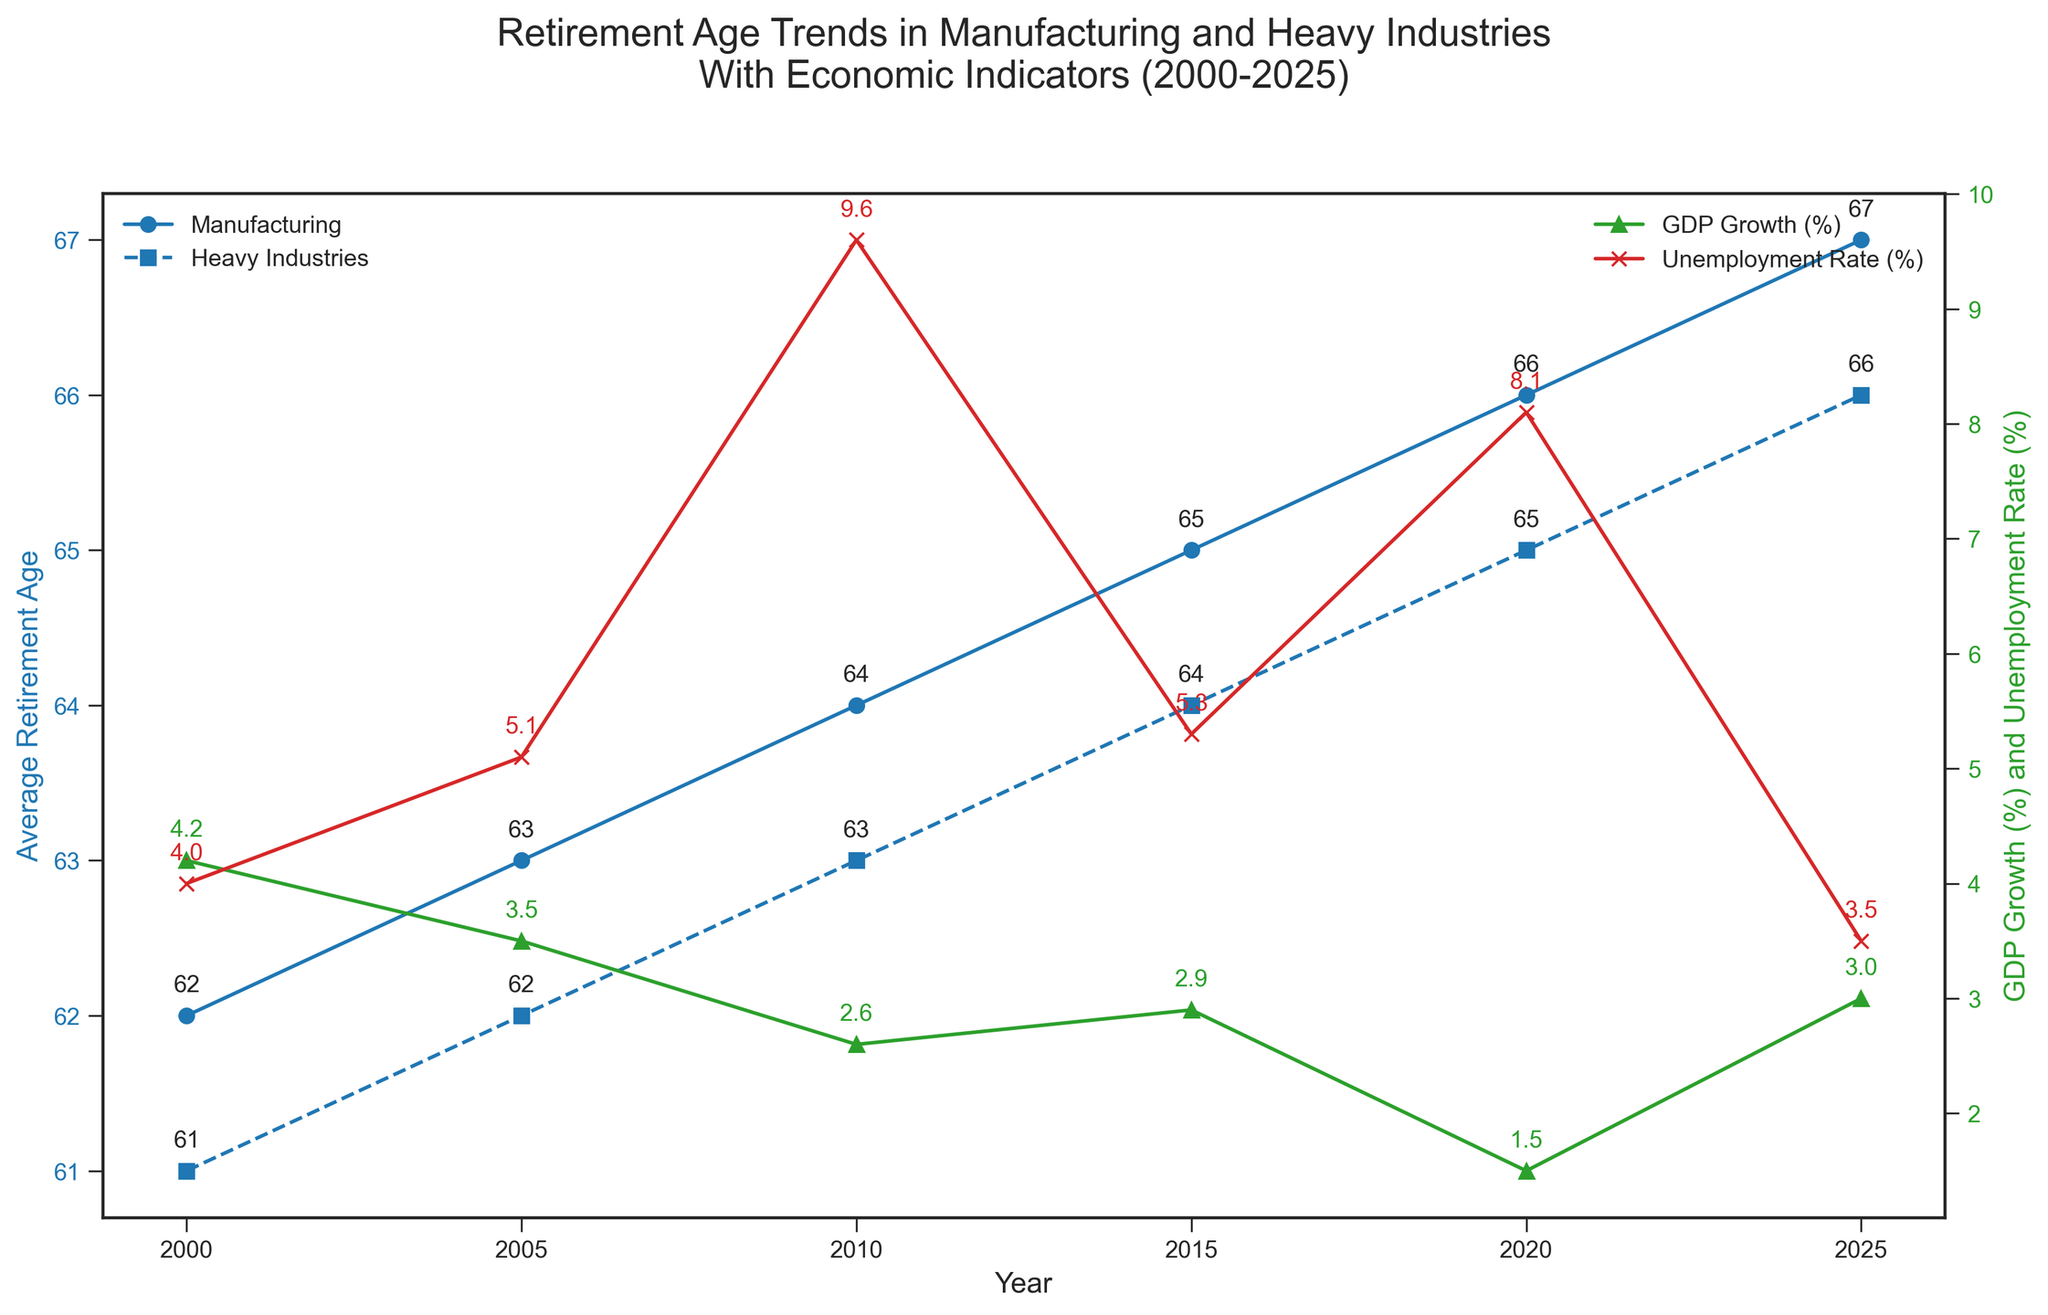What is the average retirement age for Manufacturing in 2010? From the plot, the average retirement age for Manufacturing in 2010 is labeled at 64.
Answer: 64 How much did the unemployment rate change from 2010 to 2015? In 2010, the unemployment rate is 9.6%, and in 2015, it is 5.3%. The change is 9.6% - 5.3% = 4.3%.
Answer: 4.3% Which year had the highest GDP growth rate and what was the rate? From the plot, in 2000, the GDP growth rate is the highest at 4.2%.
Answer: 2000, 4.2% How does the average retirement age in Heavy Industries in 2020 compare to that in 2000? The average retirement age in Heavy Industries in 2020 is 65 and in 2000 it is 61. The difference is 65 - 61 = 4 years.
Answer: 4 years Which year shows the largest difference in average retirement ages between Manufacturing and Heavy Industries? From visual inspection of the plot, the largest difference is in 2025, where the average retirement age in Manufacturing is 67 and in Heavy Industries is 66, a difference of 1 year.
Answer: 2025 What is the trend in average retirement age in Manufacturing from 2000 to 2025? The average retirement age in Manufacturing continuously increases from 62 in 2000 to 67 in 2025, indicating a rising trend.
Answer: Rising trend In which year was the unemployment rate at its peak? The highest unemployment rate shown in the plot is in 2010 at 9.6%.
Answer: 2010 How does the GDP growth in 2005 compare to the GDP growth in 2010? In 2005, the GDP growth is 3.5%, while in 2010, it is 2.6%. The GDP growth decreased by 3.5% - 2.6% = 0.9%.
Answer: Decreased by 0.9% What color represents unemployment rate on the plot, and how can you identify it? The unemployment rate is represented by the red line with 'x' markers on the right Y-axis. This is identified by the visual attributes and corresponding legend.
Answer: Red Compare the trend in retirement age in Heavy Industries against the trend in GDP Growth from 2010 to 2025. From 2010 to 2025, the average retirement age in Heavy Industries increases from 63 to 66, while GDP growth first increases slightly from 2.6% in 2010 to 2.9% in 2015 before a slight dip to 1.5% in 2020, and then rises again to 3.0% in 2025.
Answer: Retirement age increases, mixed trend in GDP growth 